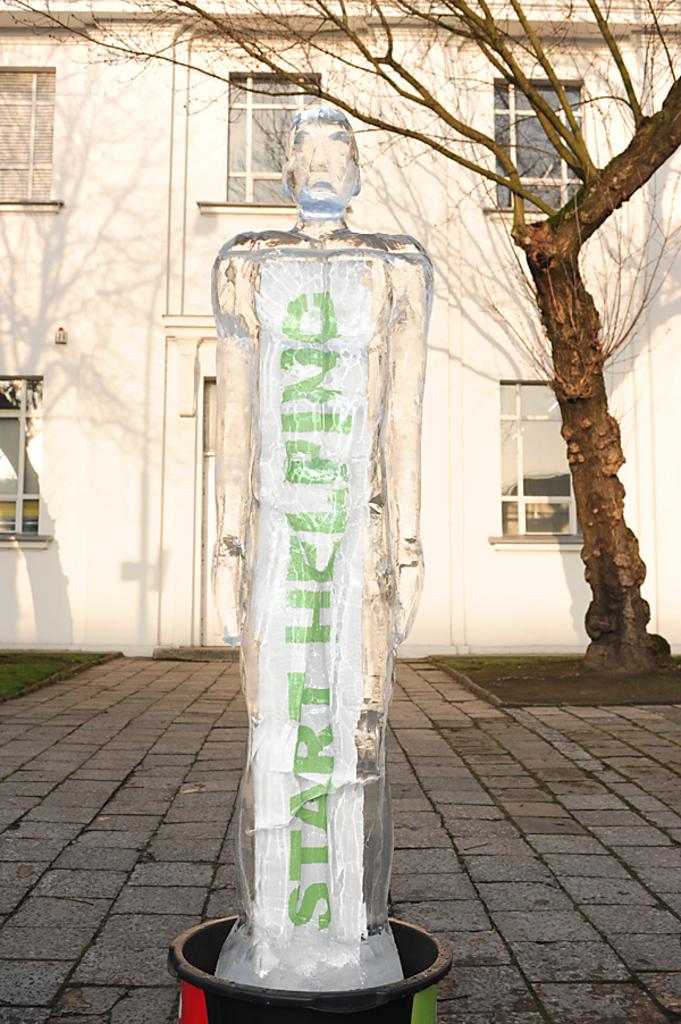What is the main subject in the image? There is a statue in the image. What is located behind the statue? There is a tree behind the statue. What type of architectural feature can be seen in the image? There are glass windows in the image. What type of structure is present in the image? There is a building in the image. What is visible at the bottom of the image? There is a floor visible at the bottom of the image. Is the person reading a book under the umbrella in the image? There is no person, reading, or umbrella present in the image. 